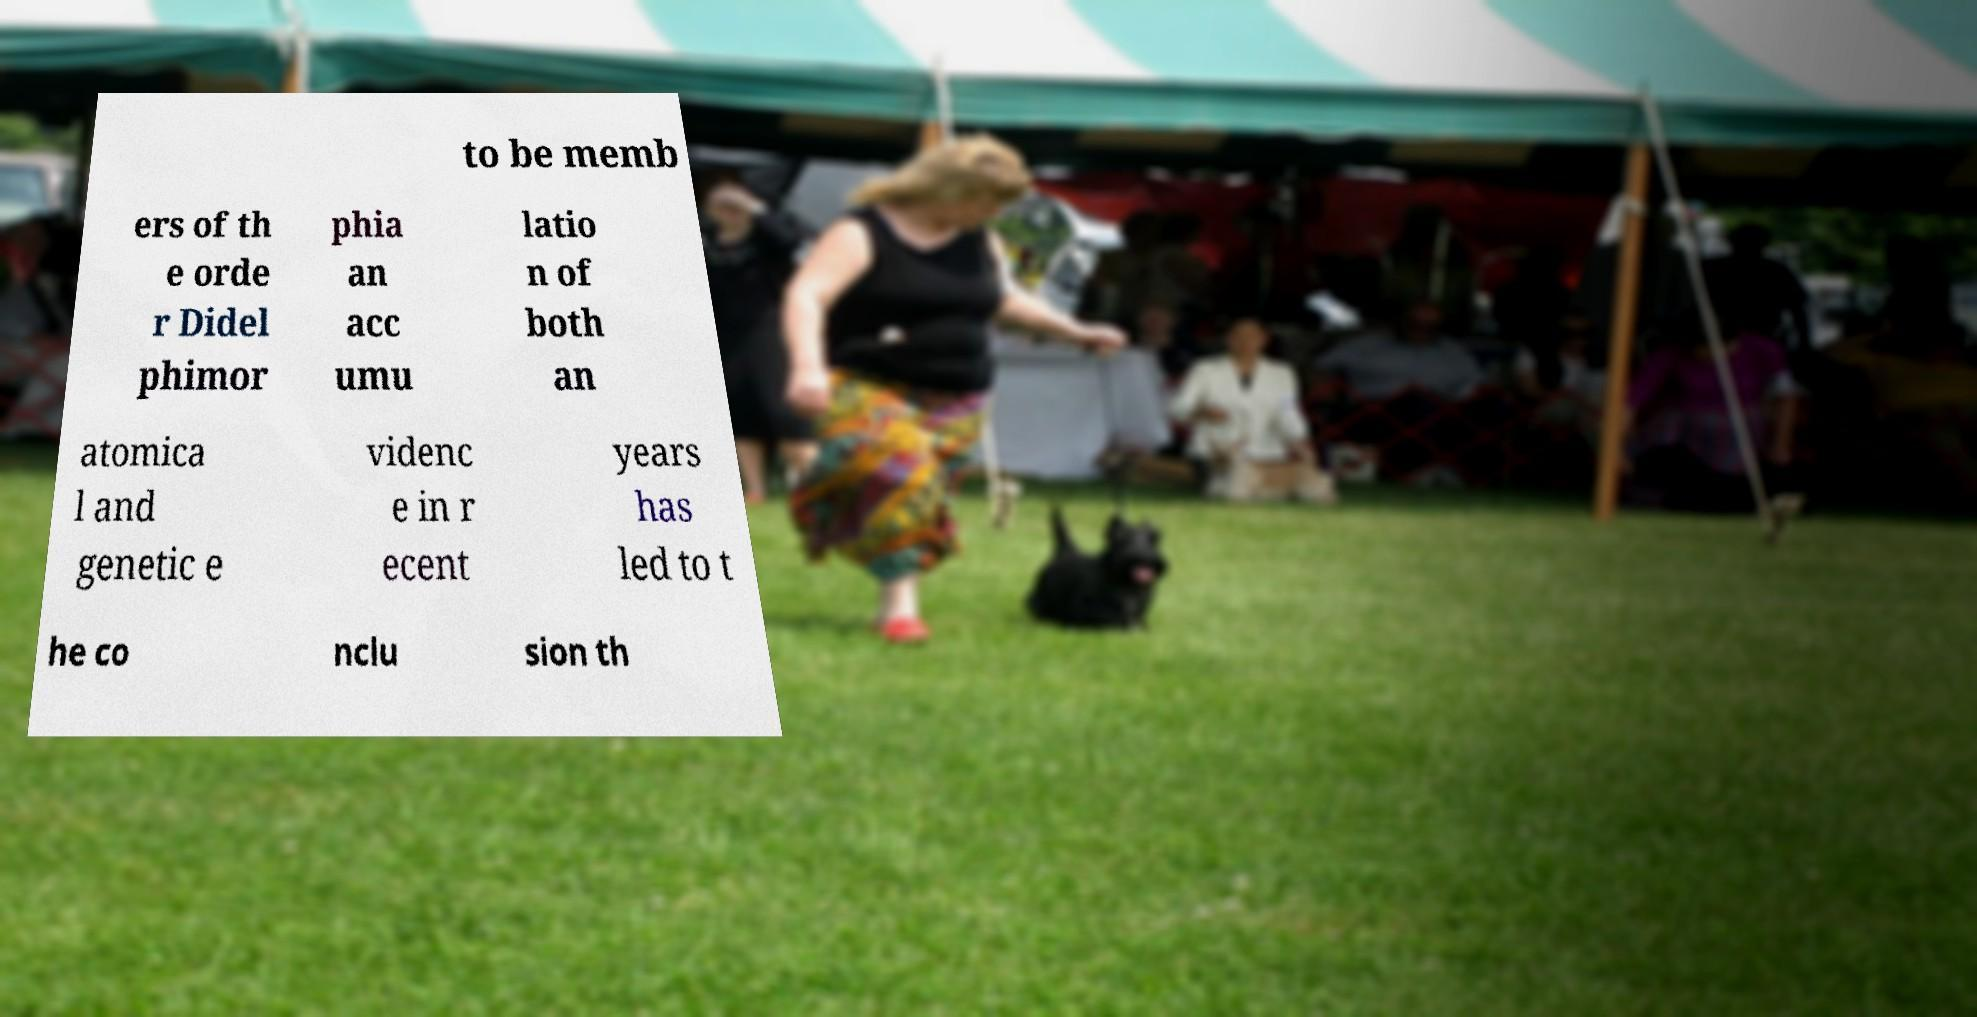There's text embedded in this image that I need extracted. Can you transcribe it verbatim? to be memb ers of th e orde r Didel phimor phia an acc umu latio n of both an atomica l and genetic e videnc e in r ecent years has led to t he co nclu sion th 